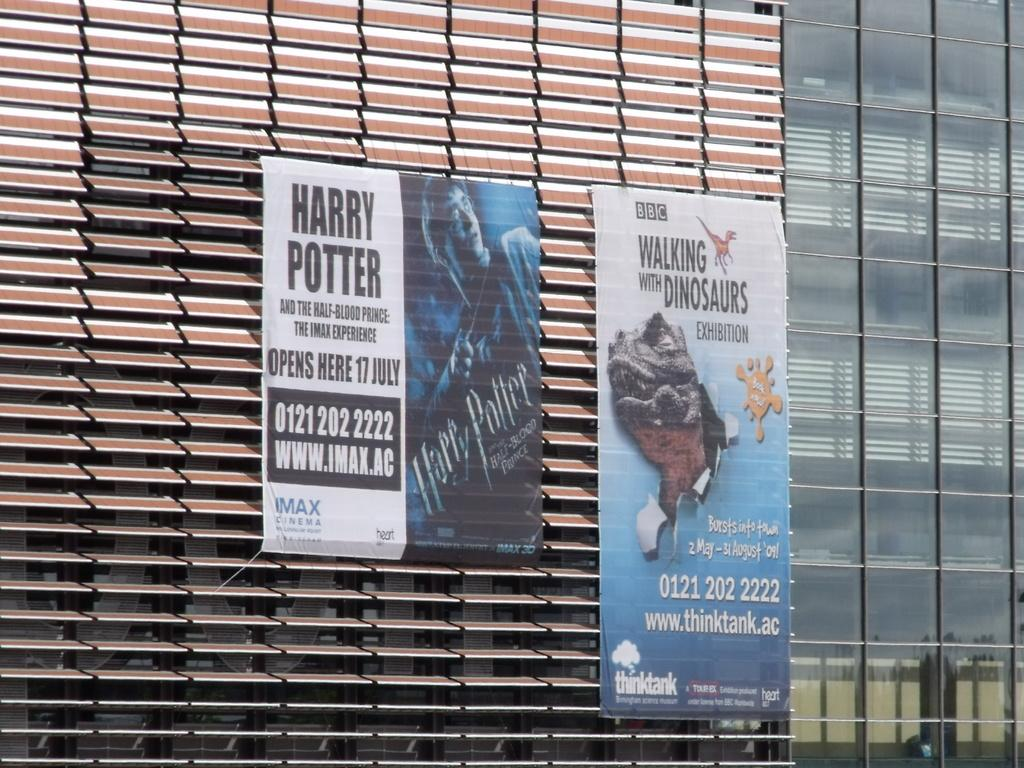<image>
Offer a succinct explanation of the picture presented. Two large banners on the side of a building advertising Harry Potter and the Walking With Dinosaurs exhibition. 